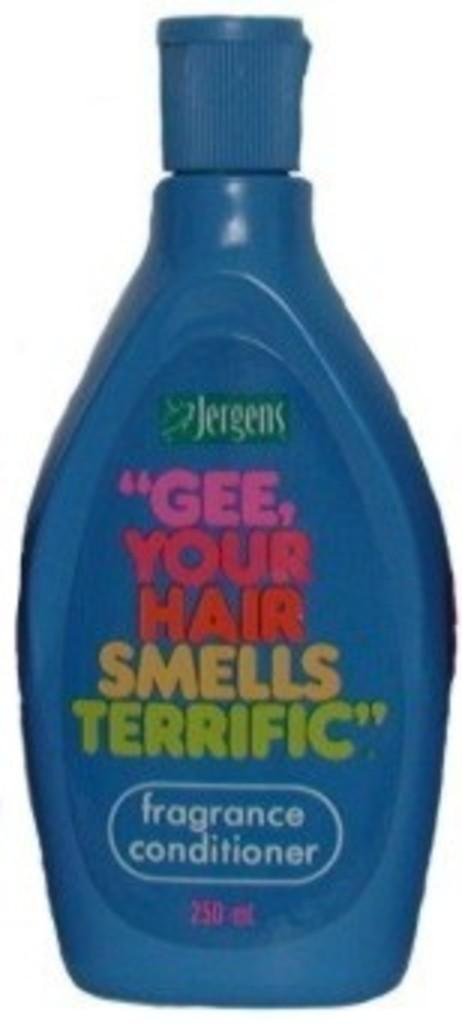Provide a one-sentence caption for the provided image. a blue plastic of fragrance conditioner by jergens. 